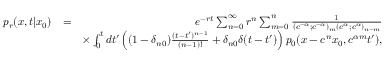Convert formula to latex. <formula><loc_0><loc_0><loc_500><loc_500>\begin{array} { r l r } { p _ { r } ( x , t | x _ { 0 } ) } & { = } & { e ^ { - r t } \sum _ { n = 0 } ^ { \infty } r ^ { n } \sum _ { m = 0 } ^ { n } \frac { 1 } { ( c ^ { - \alpha } ; c ^ { - \alpha } ) _ { m } ( c ^ { \alpha } ; c ^ { \alpha } ) _ { n - m } } } \\ & { \times \int _ { 0 } ^ { t } d t ^ { \prime } \left ( ( 1 - \delta _ { n 0 } ) \frac { ( t - t ^ { \prime } ) ^ { n - 1 } } { ( n - 1 ) ! } + \delta _ { n 0 } \delta ( t - t ^ { \prime } ) \right ) p _ { 0 } ( x - c ^ { n } x _ { 0 } , c ^ { \alpha m } t ^ { \prime } ) , } \end{array}</formula> 